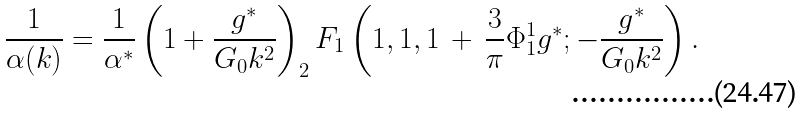<formula> <loc_0><loc_0><loc_500><loc_500>\frac { 1 } { \alpha ( k ) } = \frac { 1 } { \alpha ^ { * } } \left ( 1 + \frac { g ^ { * } } { G _ { 0 } k ^ { 2 } } \right ) _ { 2 } F _ { 1 } \left ( 1 , 1 , 1 \, + \, \frac { 3 } { \pi } \Phi ^ { 1 } _ { 1 } g ^ { * } ; - \frac { g ^ { * } } { G _ { 0 } k ^ { 2 } } \right ) .</formula> 